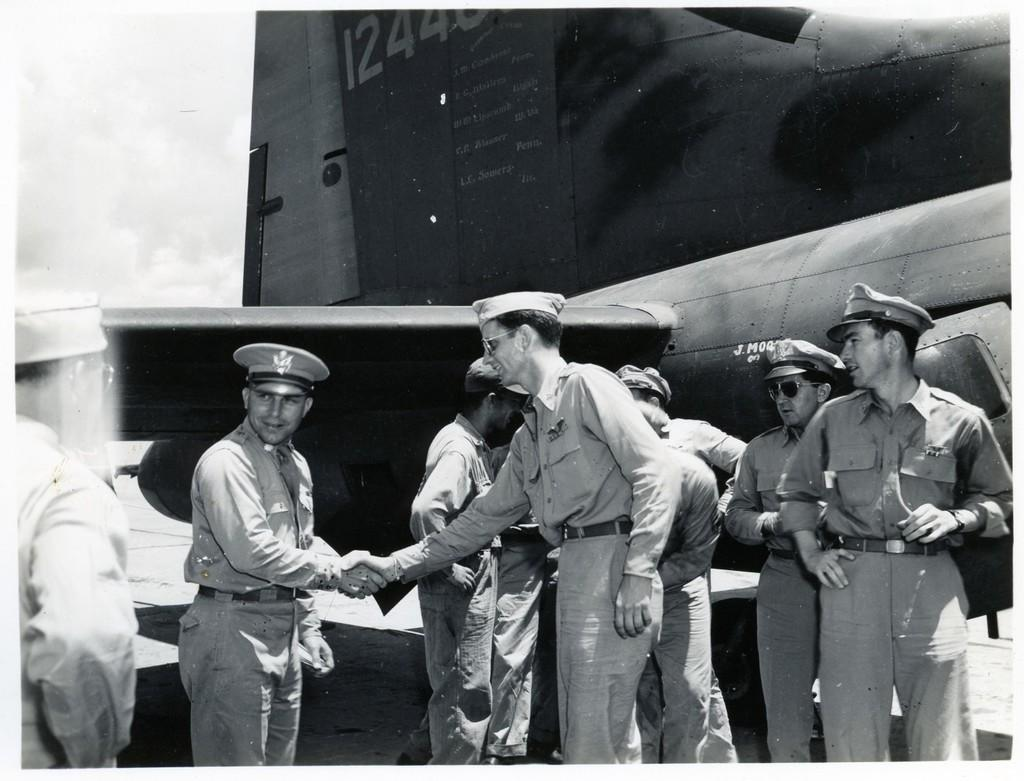<image>
Present a compact description of the photo's key features. Lt Sowers engraved on a gray airplane and W.W Lipscomb above it. 